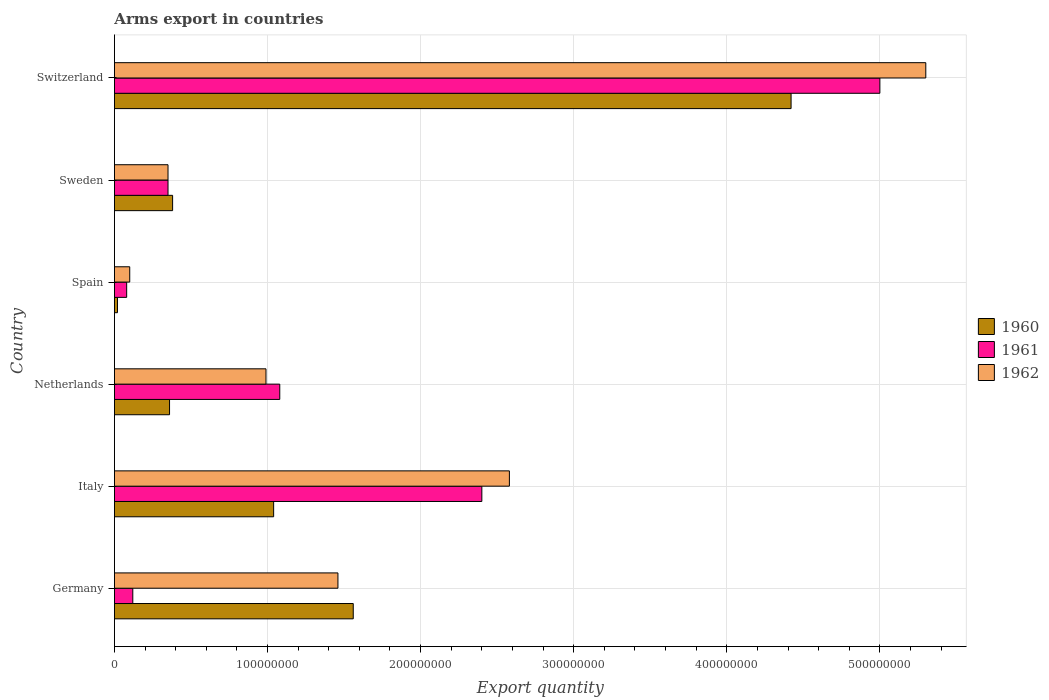In how many cases, is the number of bars for a given country not equal to the number of legend labels?
Provide a succinct answer. 0. What is the total arms export in 1961 in Italy?
Provide a short and direct response. 2.40e+08. Across all countries, what is the maximum total arms export in 1960?
Offer a terse response. 4.42e+08. Across all countries, what is the minimum total arms export in 1961?
Make the answer very short. 8.00e+06. In which country was the total arms export in 1960 maximum?
Offer a terse response. Switzerland. In which country was the total arms export in 1962 minimum?
Offer a terse response. Spain. What is the total total arms export in 1961 in the graph?
Offer a very short reply. 9.03e+08. What is the difference between the total arms export in 1961 in Germany and that in Netherlands?
Provide a short and direct response. -9.60e+07. What is the difference between the total arms export in 1962 in Germany and the total arms export in 1961 in Switzerland?
Offer a terse response. -3.54e+08. What is the average total arms export in 1962 per country?
Ensure brevity in your answer.  1.80e+08. What is the ratio of the total arms export in 1961 in Italy to that in Sweden?
Keep it short and to the point. 6.86. Is the difference between the total arms export in 1961 in Italy and Switzerland greater than the difference between the total arms export in 1960 in Italy and Switzerland?
Ensure brevity in your answer.  Yes. What is the difference between the highest and the second highest total arms export in 1961?
Offer a very short reply. 2.60e+08. What is the difference between the highest and the lowest total arms export in 1960?
Make the answer very short. 4.40e+08. In how many countries, is the total arms export in 1962 greater than the average total arms export in 1962 taken over all countries?
Provide a succinct answer. 2. What does the 2nd bar from the top in Germany represents?
Provide a short and direct response. 1961. Is it the case that in every country, the sum of the total arms export in 1960 and total arms export in 1961 is greater than the total arms export in 1962?
Your answer should be very brief. No. Are all the bars in the graph horizontal?
Offer a terse response. Yes. What is the difference between two consecutive major ticks on the X-axis?
Keep it short and to the point. 1.00e+08. Where does the legend appear in the graph?
Keep it short and to the point. Center right. How many legend labels are there?
Keep it short and to the point. 3. What is the title of the graph?
Offer a terse response. Arms export in countries. What is the label or title of the X-axis?
Provide a short and direct response. Export quantity. What is the Export quantity of 1960 in Germany?
Make the answer very short. 1.56e+08. What is the Export quantity of 1962 in Germany?
Your answer should be very brief. 1.46e+08. What is the Export quantity of 1960 in Italy?
Provide a short and direct response. 1.04e+08. What is the Export quantity of 1961 in Italy?
Make the answer very short. 2.40e+08. What is the Export quantity in 1962 in Italy?
Provide a short and direct response. 2.58e+08. What is the Export quantity in 1960 in Netherlands?
Make the answer very short. 3.60e+07. What is the Export quantity in 1961 in Netherlands?
Give a very brief answer. 1.08e+08. What is the Export quantity in 1962 in Netherlands?
Offer a very short reply. 9.90e+07. What is the Export quantity in 1961 in Spain?
Ensure brevity in your answer.  8.00e+06. What is the Export quantity of 1960 in Sweden?
Provide a short and direct response. 3.80e+07. What is the Export quantity in 1961 in Sweden?
Your response must be concise. 3.50e+07. What is the Export quantity in 1962 in Sweden?
Provide a succinct answer. 3.50e+07. What is the Export quantity of 1960 in Switzerland?
Your response must be concise. 4.42e+08. What is the Export quantity in 1962 in Switzerland?
Provide a short and direct response. 5.30e+08. Across all countries, what is the maximum Export quantity in 1960?
Give a very brief answer. 4.42e+08. Across all countries, what is the maximum Export quantity of 1961?
Provide a succinct answer. 5.00e+08. Across all countries, what is the maximum Export quantity of 1962?
Ensure brevity in your answer.  5.30e+08. Across all countries, what is the minimum Export quantity in 1960?
Make the answer very short. 2.00e+06. What is the total Export quantity of 1960 in the graph?
Provide a succinct answer. 7.78e+08. What is the total Export quantity in 1961 in the graph?
Ensure brevity in your answer.  9.03e+08. What is the total Export quantity of 1962 in the graph?
Provide a short and direct response. 1.08e+09. What is the difference between the Export quantity of 1960 in Germany and that in Italy?
Provide a succinct answer. 5.20e+07. What is the difference between the Export quantity in 1961 in Germany and that in Italy?
Give a very brief answer. -2.28e+08. What is the difference between the Export quantity of 1962 in Germany and that in Italy?
Your answer should be very brief. -1.12e+08. What is the difference between the Export quantity of 1960 in Germany and that in Netherlands?
Offer a very short reply. 1.20e+08. What is the difference between the Export quantity of 1961 in Germany and that in Netherlands?
Provide a short and direct response. -9.60e+07. What is the difference between the Export quantity in 1962 in Germany and that in Netherlands?
Your answer should be very brief. 4.70e+07. What is the difference between the Export quantity in 1960 in Germany and that in Spain?
Offer a terse response. 1.54e+08. What is the difference between the Export quantity of 1962 in Germany and that in Spain?
Your answer should be very brief. 1.36e+08. What is the difference between the Export quantity of 1960 in Germany and that in Sweden?
Your answer should be very brief. 1.18e+08. What is the difference between the Export quantity of 1961 in Germany and that in Sweden?
Offer a very short reply. -2.30e+07. What is the difference between the Export quantity in 1962 in Germany and that in Sweden?
Your answer should be compact. 1.11e+08. What is the difference between the Export quantity of 1960 in Germany and that in Switzerland?
Ensure brevity in your answer.  -2.86e+08. What is the difference between the Export quantity in 1961 in Germany and that in Switzerland?
Keep it short and to the point. -4.88e+08. What is the difference between the Export quantity in 1962 in Germany and that in Switzerland?
Offer a very short reply. -3.84e+08. What is the difference between the Export quantity of 1960 in Italy and that in Netherlands?
Ensure brevity in your answer.  6.80e+07. What is the difference between the Export quantity of 1961 in Italy and that in Netherlands?
Offer a terse response. 1.32e+08. What is the difference between the Export quantity of 1962 in Italy and that in Netherlands?
Ensure brevity in your answer.  1.59e+08. What is the difference between the Export quantity of 1960 in Italy and that in Spain?
Your response must be concise. 1.02e+08. What is the difference between the Export quantity of 1961 in Italy and that in Spain?
Ensure brevity in your answer.  2.32e+08. What is the difference between the Export quantity of 1962 in Italy and that in Spain?
Your answer should be compact. 2.48e+08. What is the difference between the Export quantity of 1960 in Italy and that in Sweden?
Your answer should be very brief. 6.60e+07. What is the difference between the Export quantity of 1961 in Italy and that in Sweden?
Make the answer very short. 2.05e+08. What is the difference between the Export quantity of 1962 in Italy and that in Sweden?
Offer a terse response. 2.23e+08. What is the difference between the Export quantity of 1960 in Italy and that in Switzerland?
Make the answer very short. -3.38e+08. What is the difference between the Export quantity of 1961 in Italy and that in Switzerland?
Give a very brief answer. -2.60e+08. What is the difference between the Export quantity in 1962 in Italy and that in Switzerland?
Your response must be concise. -2.72e+08. What is the difference between the Export quantity of 1960 in Netherlands and that in Spain?
Your answer should be very brief. 3.40e+07. What is the difference between the Export quantity of 1962 in Netherlands and that in Spain?
Provide a short and direct response. 8.90e+07. What is the difference between the Export quantity of 1960 in Netherlands and that in Sweden?
Provide a succinct answer. -2.00e+06. What is the difference between the Export quantity in 1961 in Netherlands and that in Sweden?
Keep it short and to the point. 7.30e+07. What is the difference between the Export quantity in 1962 in Netherlands and that in Sweden?
Your answer should be compact. 6.40e+07. What is the difference between the Export quantity of 1960 in Netherlands and that in Switzerland?
Give a very brief answer. -4.06e+08. What is the difference between the Export quantity in 1961 in Netherlands and that in Switzerland?
Your answer should be compact. -3.92e+08. What is the difference between the Export quantity of 1962 in Netherlands and that in Switzerland?
Make the answer very short. -4.31e+08. What is the difference between the Export quantity in 1960 in Spain and that in Sweden?
Your answer should be very brief. -3.60e+07. What is the difference between the Export quantity in 1961 in Spain and that in Sweden?
Make the answer very short. -2.70e+07. What is the difference between the Export quantity in 1962 in Spain and that in Sweden?
Your response must be concise. -2.50e+07. What is the difference between the Export quantity in 1960 in Spain and that in Switzerland?
Keep it short and to the point. -4.40e+08. What is the difference between the Export quantity in 1961 in Spain and that in Switzerland?
Your answer should be very brief. -4.92e+08. What is the difference between the Export quantity in 1962 in Spain and that in Switzerland?
Provide a succinct answer. -5.20e+08. What is the difference between the Export quantity of 1960 in Sweden and that in Switzerland?
Offer a very short reply. -4.04e+08. What is the difference between the Export quantity of 1961 in Sweden and that in Switzerland?
Keep it short and to the point. -4.65e+08. What is the difference between the Export quantity in 1962 in Sweden and that in Switzerland?
Provide a succinct answer. -4.95e+08. What is the difference between the Export quantity of 1960 in Germany and the Export quantity of 1961 in Italy?
Your response must be concise. -8.40e+07. What is the difference between the Export quantity of 1960 in Germany and the Export quantity of 1962 in Italy?
Keep it short and to the point. -1.02e+08. What is the difference between the Export quantity of 1961 in Germany and the Export quantity of 1962 in Italy?
Provide a succinct answer. -2.46e+08. What is the difference between the Export quantity of 1960 in Germany and the Export quantity of 1961 in Netherlands?
Make the answer very short. 4.80e+07. What is the difference between the Export quantity of 1960 in Germany and the Export quantity of 1962 in Netherlands?
Your answer should be very brief. 5.70e+07. What is the difference between the Export quantity of 1961 in Germany and the Export quantity of 1962 in Netherlands?
Offer a terse response. -8.70e+07. What is the difference between the Export quantity in 1960 in Germany and the Export quantity in 1961 in Spain?
Give a very brief answer. 1.48e+08. What is the difference between the Export quantity in 1960 in Germany and the Export quantity in 1962 in Spain?
Your answer should be compact. 1.46e+08. What is the difference between the Export quantity in 1961 in Germany and the Export quantity in 1962 in Spain?
Provide a short and direct response. 2.00e+06. What is the difference between the Export quantity in 1960 in Germany and the Export quantity in 1961 in Sweden?
Provide a succinct answer. 1.21e+08. What is the difference between the Export quantity in 1960 in Germany and the Export quantity in 1962 in Sweden?
Provide a short and direct response. 1.21e+08. What is the difference between the Export quantity of 1961 in Germany and the Export quantity of 1962 in Sweden?
Your answer should be very brief. -2.30e+07. What is the difference between the Export quantity of 1960 in Germany and the Export quantity of 1961 in Switzerland?
Your answer should be very brief. -3.44e+08. What is the difference between the Export quantity in 1960 in Germany and the Export quantity in 1962 in Switzerland?
Offer a very short reply. -3.74e+08. What is the difference between the Export quantity in 1961 in Germany and the Export quantity in 1962 in Switzerland?
Offer a terse response. -5.18e+08. What is the difference between the Export quantity in 1960 in Italy and the Export quantity in 1961 in Netherlands?
Provide a short and direct response. -4.00e+06. What is the difference between the Export quantity of 1961 in Italy and the Export quantity of 1962 in Netherlands?
Your answer should be very brief. 1.41e+08. What is the difference between the Export quantity in 1960 in Italy and the Export quantity in 1961 in Spain?
Keep it short and to the point. 9.60e+07. What is the difference between the Export quantity of 1960 in Italy and the Export quantity of 1962 in Spain?
Provide a succinct answer. 9.40e+07. What is the difference between the Export quantity of 1961 in Italy and the Export quantity of 1962 in Spain?
Offer a terse response. 2.30e+08. What is the difference between the Export quantity in 1960 in Italy and the Export quantity in 1961 in Sweden?
Your response must be concise. 6.90e+07. What is the difference between the Export quantity of 1960 in Italy and the Export quantity of 1962 in Sweden?
Ensure brevity in your answer.  6.90e+07. What is the difference between the Export quantity in 1961 in Italy and the Export quantity in 1962 in Sweden?
Your response must be concise. 2.05e+08. What is the difference between the Export quantity of 1960 in Italy and the Export quantity of 1961 in Switzerland?
Offer a very short reply. -3.96e+08. What is the difference between the Export quantity of 1960 in Italy and the Export quantity of 1962 in Switzerland?
Keep it short and to the point. -4.26e+08. What is the difference between the Export quantity in 1961 in Italy and the Export quantity in 1962 in Switzerland?
Provide a short and direct response. -2.90e+08. What is the difference between the Export quantity of 1960 in Netherlands and the Export quantity of 1961 in Spain?
Offer a very short reply. 2.80e+07. What is the difference between the Export quantity in 1960 in Netherlands and the Export quantity in 1962 in Spain?
Offer a terse response. 2.60e+07. What is the difference between the Export quantity in 1961 in Netherlands and the Export quantity in 1962 in Spain?
Keep it short and to the point. 9.80e+07. What is the difference between the Export quantity in 1961 in Netherlands and the Export quantity in 1962 in Sweden?
Your response must be concise. 7.30e+07. What is the difference between the Export quantity in 1960 in Netherlands and the Export quantity in 1961 in Switzerland?
Offer a terse response. -4.64e+08. What is the difference between the Export quantity in 1960 in Netherlands and the Export quantity in 1962 in Switzerland?
Give a very brief answer. -4.94e+08. What is the difference between the Export quantity of 1961 in Netherlands and the Export quantity of 1962 in Switzerland?
Your response must be concise. -4.22e+08. What is the difference between the Export quantity of 1960 in Spain and the Export quantity of 1961 in Sweden?
Give a very brief answer. -3.30e+07. What is the difference between the Export quantity in 1960 in Spain and the Export quantity in 1962 in Sweden?
Your answer should be very brief. -3.30e+07. What is the difference between the Export quantity of 1961 in Spain and the Export quantity of 1962 in Sweden?
Provide a succinct answer. -2.70e+07. What is the difference between the Export quantity of 1960 in Spain and the Export quantity of 1961 in Switzerland?
Make the answer very short. -4.98e+08. What is the difference between the Export quantity in 1960 in Spain and the Export quantity in 1962 in Switzerland?
Keep it short and to the point. -5.28e+08. What is the difference between the Export quantity of 1961 in Spain and the Export quantity of 1962 in Switzerland?
Keep it short and to the point. -5.22e+08. What is the difference between the Export quantity of 1960 in Sweden and the Export quantity of 1961 in Switzerland?
Give a very brief answer. -4.62e+08. What is the difference between the Export quantity of 1960 in Sweden and the Export quantity of 1962 in Switzerland?
Provide a succinct answer. -4.92e+08. What is the difference between the Export quantity of 1961 in Sweden and the Export quantity of 1962 in Switzerland?
Make the answer very short. -4.95e+08. What is the average Export quantity of 1960 per country?
Provide a succinct answer. 1.30e+08. What is the average Export quantity in 1961 per country?
Offer a terse response. 1.50e+08. What is the average Export quantity in 1962 per country?
Offer a very short reply. 1.80e+08. What is the difference between the Export quantity of 1960 and Export quantity of 1961 in Germany?
Make the answer very short. 1.44e+08. What is the difference between the Export quantity of 1960 and Export quantity of 1962 in Germany?
Offer a terse response. 1.00e+07. What is the difference between the Export quantity in 1961 and Export quantity in 1962 in Germany?
Your answer should be very brief. -1.34e+08. What is the difference between the Export quantity in 1960 and Export quantity in 1961 in Italy?
Offer a terse response. -1.36e+08. What is the difference between the Export quantity in 1960 and Export quantity in 1962 in Italy?
Provide a succinct answer. -1.54e+08. What is the difference between the Export quantity of 1961 and Export quantity of 1962 in Italy?
Provide a succinct answer. -1.80e+07. What is the difference between the Export quantity of 1960 and Export quantity of 1961 in Netherlands?
Offer a very short reply. -7.20e+07. What is the difference between the Export quantity in 1960 and Export quantity in 1962 in Netherlands?
Ensure brevity in your answer.  -6.30e+07. What is the difference between the Export quantity of 1961 and Export quantity of 1962 in Netherlands?
Keep it short and to the point. 9.00e+06. What is the difference between the Export quantity of 1960 and Export quantity of 1961 in Spain?
Your answer should be compact. -6.00e+06. What is the difference between the Export quantity in 1960 and Export quantity in 1962 in Spain?
Your response must be concise. -8.00e+06. What is the difference between the Export quantity of 1960 and Export quantity of 1961 in Switzerland?
Make the answer very short. -5.80e+07. What is the difference between the Export quantity of 1960 and Export quantity of 1962 in Switzerland?
Keep it short and to the point. -8.80e+07. What is the difference between the Export quantity in 1961 and Export quantity in 1962 in Switzerland?
Offer a terse response. -3.00e+07. What is the ratio of the Export quantity in 1960 in Germany to that in Italy?
Make the answer very short. 1.5. What is the ratio of the Export quantity in 1962 in Germany to that in Italy?
Ensure brevity in your answer.  0.57. What is the ratio of the Export quantity in 1960 in Germany to that in Netherlands?
Offer a very short reply. 4.33. What is the ratio of the Export quantity in 1962 in Germany to that in Netherlands?
Provide a succinct answer. 1.47. What is the ratio of the Export quantity of 1960 in Germany to that in Spain?
Ensure brevity in your answer.  78. What is the ratio of the Export quantity in 1960 in Germany to that in Sweden?
Give a very brief answer. 4.11. What is the ratio of the Export quantity of 1961 in Germany to that in Sweden?
Your answer should be very brief. 0.34. What is the ratio of the Export quantity in 1962 in Germany to that in Sweden?
Keep it short and to the point. 4.17. What is the ratio of the Export quantity in 1960 in Germany to that in Switzerland?
Provide a succinct answer. 0.35. What is the ratio of the Export quantity of 1961 in Germany to that in Switzerland?
Your response must be concise. 0.02. What is the ratio of the Export quantity of 1962 in Germany to that in Switzerland?
Make the answer very short. 0.28. What is the ratio of the Export quantity of 1960 in Italy to that in Netherlands?
Your answer should be compact. 2.89. What is the ratio of the Export quantity of 1961 in Italy to that in Netherlands?
Your answer should be compact. 2.22. What is the ratio of the Export quantity in 1962 in Italy to that in Netherlands?
Your answer should be compact. 2.61. What is the ratio of the Export quantity in 1962 in Italy to that in Spain?
Give a very brief answer. 25.8. What is the ratio of the Export quantity of 1960 in Italy to that in Sweden?
Make the answer very short. 2.74. What is the ratio of the Export quantity of 1961 in Italy to that in Sweden?
Your answer should be very brief. 6.86. What is the ratio of the Export quantity in 1962 in Italy to that in Sweden?
Your answer should be compact. 7.37. What is the ratio of the Export quantity of 1960 in Italy to that in Switzerland?
Make the answer very short. 0.24. What is the ratio of the Export quantity in 1961 in Italy to that in Switzerland?
Your response must be concise. 0.48. What is the ratio of the Export quantity in 1962 in Italy to that in Switzerland?
Your answer should be very brief. 0.49. What is the ratio of the Export quantity of 1960 in Netherlands to that in Sweden?
Make the answer very short. 0.95. What is the ratio of the Export quantity of 1961 in Netherlands to that in Sweden?
Your answer should be very brief. 3.09. What is the ratio of the Export quantity of 1962 in Netherlands to that in Sweden?
Provide a succinct answer. 2.83. What is the ratio of the Export quantity in 1960 in Netherlands to that in Switzerland?
Your response must be concise. 0.08. What is the ratio of the Export quantity of 1961 in Netherlands to that in Switzerland?
Give a very brief answer. 0.22. What is the ratio of the Export quantity of 1962 in Netherlands to that in Switzerland?
Offer a terse response. 0.19. What is the ratio of the Export quantity in 1960 in Spain to that in Sweden?
Offer a very short reply. 0.05. What is the ratio of the Export quantity of 1961 in Spain to that in Sweden?
Your response must be concise. 0.23. What is the ratio of the Export quantity in 1962 in Spain to that in Sweden?
Offer a terse response. 0.29. What is the ratio of the Export quantity in 1960 in Spain to that in Switzerland?
Offer a terse response. 0. What is the ratio of the Export quantity of 1961 in Spain to that in Switzerland?
Make the answer very short. 0.02. What is the ratio of the Export quantity in 1962 in Spain to that in Switzerland?
Offer a very short reply. 0.02. What is the ratio of the Export quantity of 1960 in Sweden to that in Switzerland?
Your answer should be very brief. 0.09. What is the ratio of the Export quantity in 1961 in Sweden to that in Switzerland?
Give a very brief answer. 0.07. What is the ratio of the Export quantity in 1962 in Sweden to that in Switzerland?
Provide a succinct answer. 0.07. What is the difference between the highest and the second highest Export quantity in 1960?
Your response must be concise. 2.86e+08. What is the difference between the highest and the second highest Export quantity in 1961?
Offer a very short reply. 2.60e+08. What is the difference between the highest and the second highest Export quantity of 1962?
Make the answer very short. 2.72e+08. What is the difference between the highest and the lowest Export quantity of 1960?
Your answer should be very brief. 4.40e+08. What is the difference between the highest and the lowest Export quantity in 1961?
Provide a short and direct response. 4.92e+08. What is the difference between the highest and the lowest Export quantity of 1962?
Provide a succinct answer. 5.20e+08. 